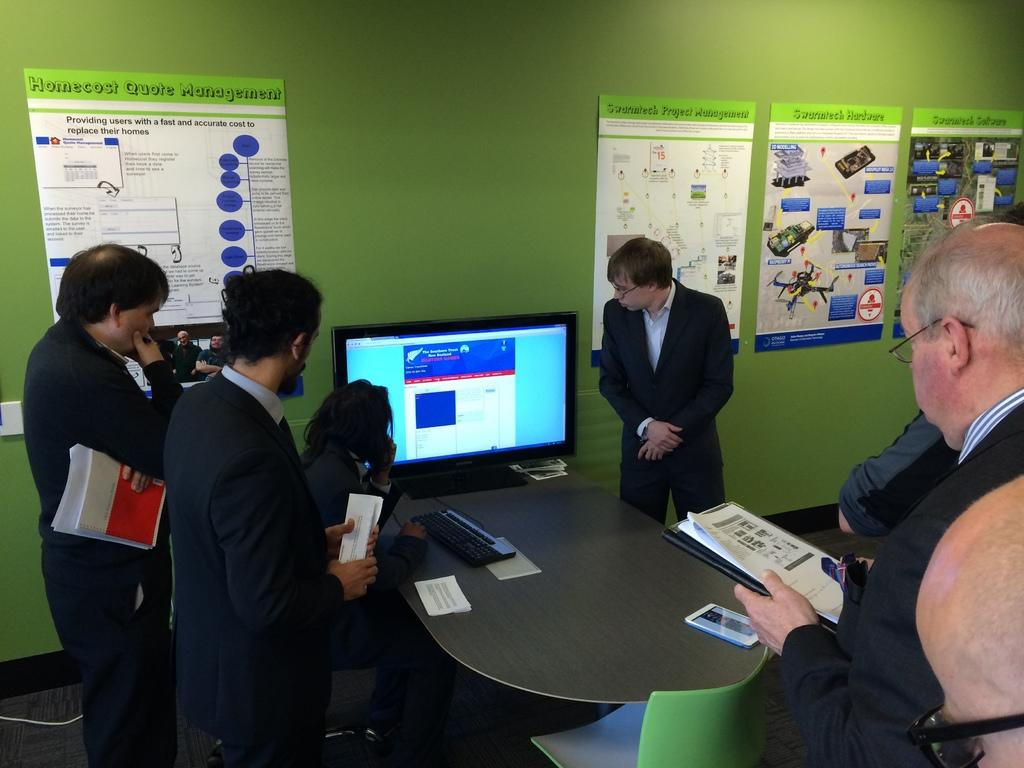What are the people in the image doing? The people in the image are standing and holding papers. What object can be seen on a table in the image? There is a television on a table in the image. What is attached to the wall in the image? There are posts on a wall in the image. How does the yoke help the people in the image? There is no yoke present in the image, so it cannot help the people in any way. 